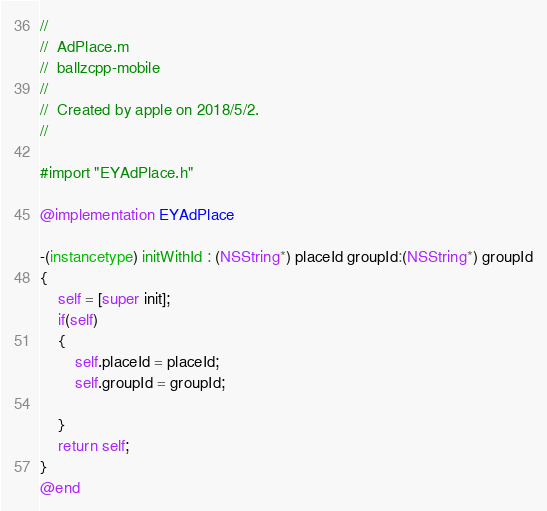Convert code to text. <code><loc_0><loc_0><loc_500><loc_500><_ObjectiveC_>//
//  AdPlace.m
//  ballzcpp-mobile
//
//  Created by apple on 2018/5/2.
//

#import "EYAdPlace.h"

@implementation EYAdPlace

-(instancetype) initWithId : (NSString*) placeId groupId:(NSString*) groupId
{
    self = [super init];
    if(self)
    {
        self.placeId = placeId;
        self.groupId = groupId;
        
    }
    return self;
}
@end
</code> 